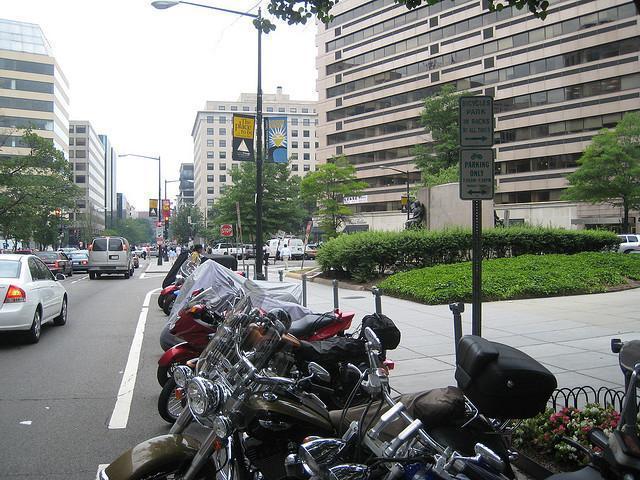What types of people use this part of the street the most?
Select the accurate answer and provide explanation: 'Answer: answer
Rationale: rationale.'
Options: Taxi drivers, truckers, motorcyclists, pedestrians. Answer: motorcyclists.
Rationale: The vehicles are  motorbikes and are driven by motorcyclists. 